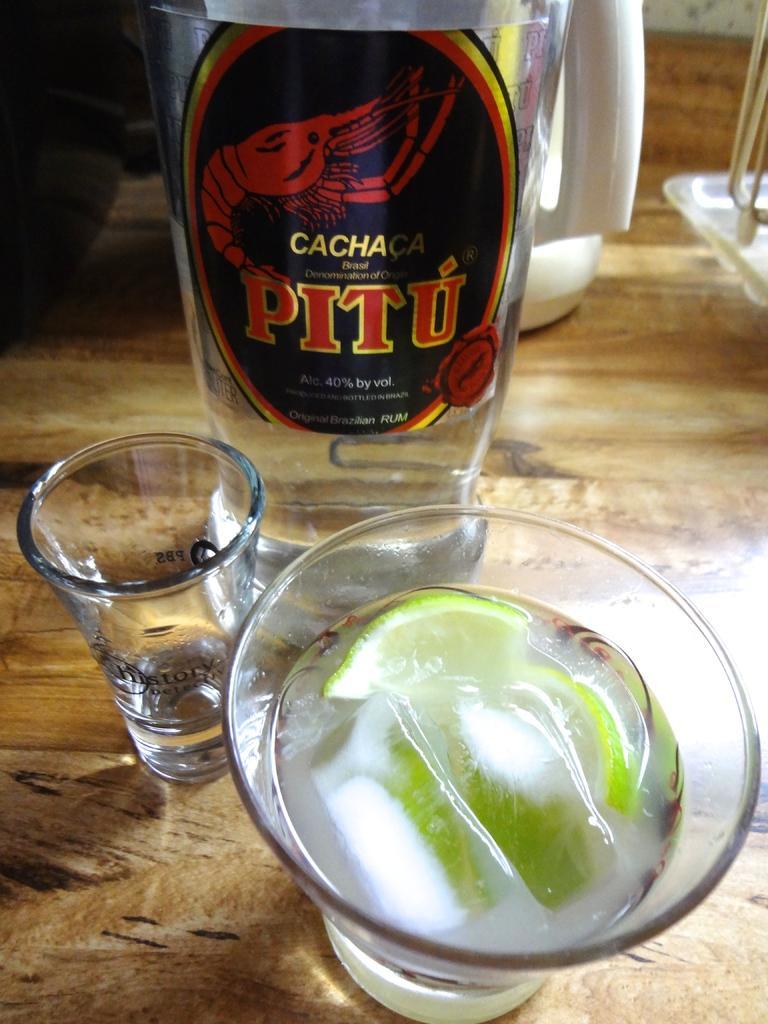Can you describe this image briefly? In the picture I can see a glass of drink which has few ice cubes and lemon slices in it in the right corner and there is another glass beside it and there is a glass bottle which has drink in it in the background. 